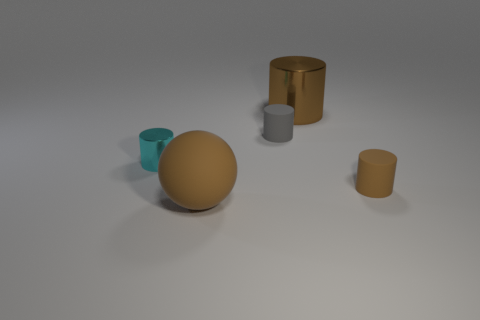There is a tiny cylinder that is right of the gray rubber cylinder; is its color the same as the cylinder to the left of the large brown matte sphere?
Offer a terse response. No. Are there any cyan shiny cylinders of the same size as the brown rubber cylinder?
Your response must be concise. Yes. What is the material of the brown object that is both in front of the tiny cyan metallic object and to the right of the large brown matte ball?
Your response must be concise. Rubber. What number of matte things are either brown cylinders or gray cylinders?
Ensure brevity in your answer.  2. There is a small brown object that is made of the same material as the brown sphere; what shape is it?
Make the answer very short. Cylinder. What number of objects are both in front of the large brown cylinder and to the left of the small brown cylinder?
Your answer should be compact. 3. Is there any other thing that has the same shape as the small metallic object?
Offer a very short reply. Yes. There is a matte cylinder on the left side of the brown metal cylinder; what is its size?
Offer a terse response. Small. How many other things are the same color as the large rubber sphere?
Your answer should be very brief. 2. There is a brown cylinder behind the brown cylinder that is in front of the cyan metallic cylinder; what is it made of?
Offer a terse response. Metal. 